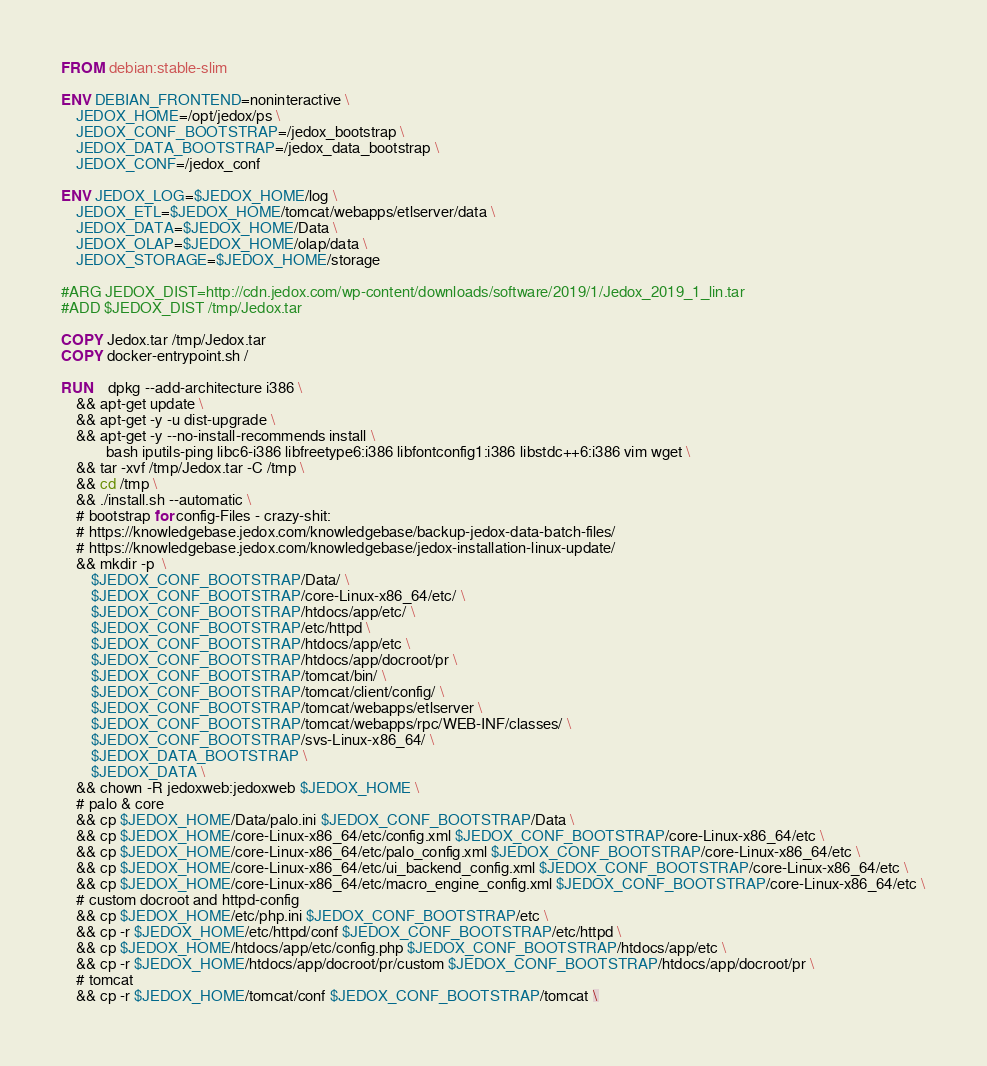<code> <loc_0><loc_0><loc_500><loc_500><_Dockerfile_>FROM debian:stable-slim

ENV DEBIAN_FRONTEND=noninteractive \
    JEDOX_HOME=/opt/jedox/ps \
    JEDOX_CONF_BOOTSTRAP=/jedox_bootstrap \
    JEDOX_DATA_BOOTSTRAP=/jedox_data_bootstrap \
    JEDOX_CONF=/jedox_conf

ENV JEDOX_LOG=$JEDOX_HOME/log \
    JEDOX_ETL=$JEDOX_HOME/tomcat/webapps/etlserver/data \
    JEDOX_DATA=$JEDOX_HOME/Data \
    JEDOX_OLAP=$JEDOX_HOME/olap/data \
    JEDOX_STORAGE=$JEDOX_HOME/storage

#ARG JEDOX_DIST=http://cdn.jedox.com/wp-content/downloads/software/2019/1/Jedox_2019_1_lin.tar
#ADD $JEDOX_DIST /tmp/Jedox.tar

COPY Jedox.tar /tmp/Jedox.tar
COPY docker-entrypoint.sh /

RUN    dpkg --add-architecture i386 \
    && apt-get update \
    && apt-get -y -u dist-upgrade \
    && apt-get -y --no-install-recommends install \
            bash iputils-ping libc6-i386 libfreetype6:i386 libfontconfig1:i386 libstdc++6:i386 vim wget \
    && tar -xvf /tmp/Jedox.tar -C /tmp \
    && cd /tmp \
    && ./install.sh --automatic \
    # bootstrap for config-Files - crazy-shit:
    # https://knowledgebase.jedox.com/knowledgebase/backup-jedox-data-batch-files/
    # https://knowledgebase.jedox.com/knowledgebase/jedox-installation-linux-update/
    && mkdir -p  \
        $JEDOX_CONF_BOOTSTRAP/Data/ \
        $JEDOX_CONF_BOOTSTRAP/core-Linux-x86_64/etc/ \
        $JEDOX_CONF_BOOTSTRAP/htdocs/app/etc/ \
        $JEDOX_CONF_BOOTSTRAP/etc/httpd \
        $JEDOX_CONF_BOOTSTRAP/htdocs/app/etc \
        $JEDOX_CONF_BOOTSTRAP/htdocs/app/docroot/pr \
        $JEDOX_CONF_BOOTSTRAP/tomcat/bin/ \
        $JEDOX_CONF_BOOTSTRAP/tomcat/client/config/ \
        $JEDOX_CONF_BOOTSTRAP/tomcat/webapps/etlserver \
        $JEDOX_CONF_BOOTSTRAP/tomcat/webapps/rpc/WEB-INF/classes/ \
        $JEDOX_CONF_BOOTSTRAP/svs-Linux-x86_64/ \
        $JEDOX_DATA_BOOTSTRAP \
        $JEDOX_DATA \
    && chown -R jedoxweb:jedoxweb $JEDOX_HOME \
    # palo & core
    && cp $JEDOX_HOME/Data/palo.ini $JEDOX_CONF_BOOTSTRAP/Data \
    && cp $JEDOX_HOME/core-Linux-x86_64/etc/config.xml $JEDOX_CONF_BOOTSTRAP/core-Linux-x86_64/etc \
    && cp $JEDOX_HOME/core-Linux-x86_64/etc/palo_config.xml $JEDOX_CONF_BOOTSTRAP/core-Linux-x86_64/etc \
    && cp $JEDOX_HOME/core-Linux-x86_64/etc/ui_backend_config.xml $JEDOX_CONF_BOOTSTRAP/core-Linux-x86_64/etc \
    && cp $JEDOX_HOME/core-Linux-x86_64/etc/macro_engine_config.xml $JEDOX_CONF_BOOTSTRAP/core-Linux-x86_64/etc \
    # custom docroot and httpd-config
    && cp $JEDOX_HOME/etc/php.ini $JEDOX_CONF_BOOTSTRAP/etc \
    && cp -r $JEDOX_HOME/etc/httpd/conf $JEDOX_CONF_BOOTSTRAP/etc/httpd \
    && cp $JEDOX_HOME/htdocs/app/etc/config.php $JEDOX_CONF_BOOTSTRAP/htdocs/app/etc \
    && cp -r $JEDOX_HOME/htdocs/app/docroot/pr/custom $JEDOX_CONF_BOOTSTRAP/htdocs/app/docroot/pr \
    # tomcat
    && cp -r $JEDOX_HOME/tomcat/conf $JEDOX_CONF_BOOTSTRAP/tomcat \</code> 